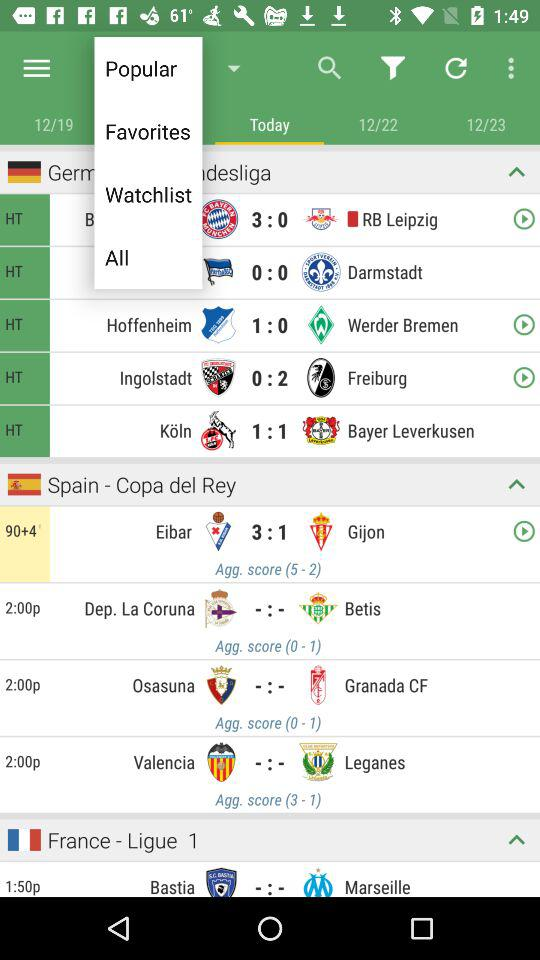Which tab is selected? The selected tab is "Standings". 